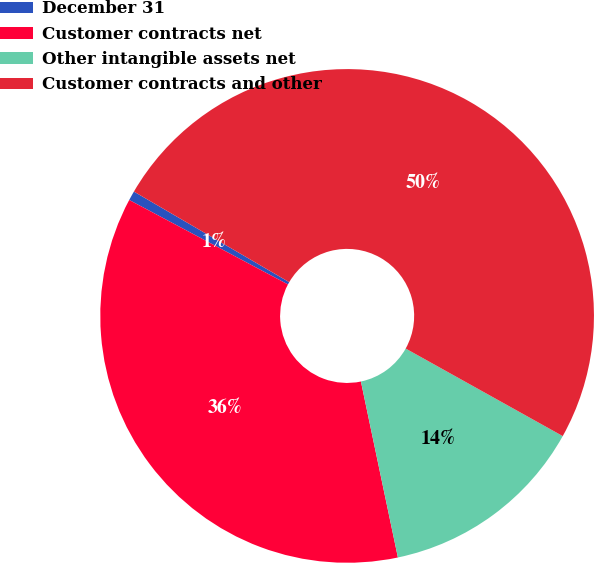Convert chart to OTSL. <chart><loc_0><loc_0><loc_500><loc_500><pie_chart><fcel>December 31<fcel>Customer contracts net<fcel>Other intangible assets net<fcel>Customer contracts and other<nl><fcel>0.62%<fcel>36.08%<fcel>13.61%<fcel>49.69%<nl></chart> 